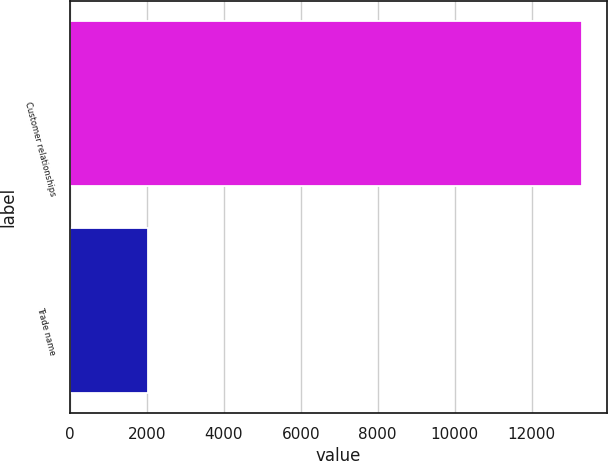Convert chart. <chart><loc_0><loc_0><loc_500><loc_500><bar_chart><fcel>Customer relationships<fcel>Trade name<nl><fcel>13297<fcel>2023<nl></chart> 